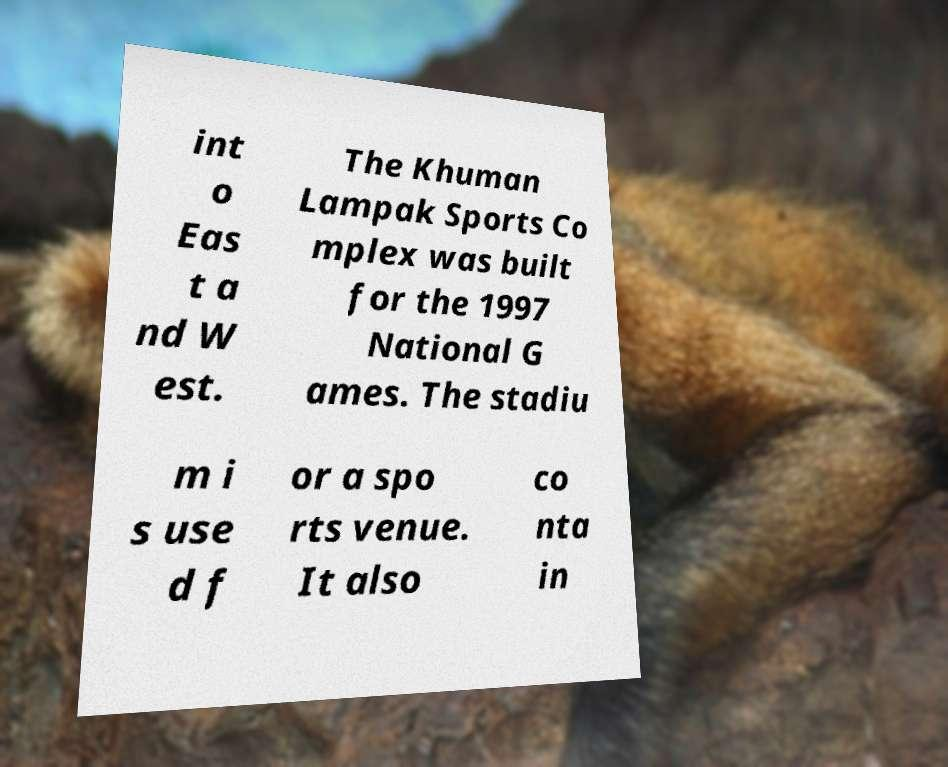Can you accurately transcribe the text from the provided image for me? int o Eas t a nd W est. The Khuman Lampak Sports Co mplex was built for the 1997 National G ames. The stadiu m i s use d f or a spo rts venue. It also co nta in 